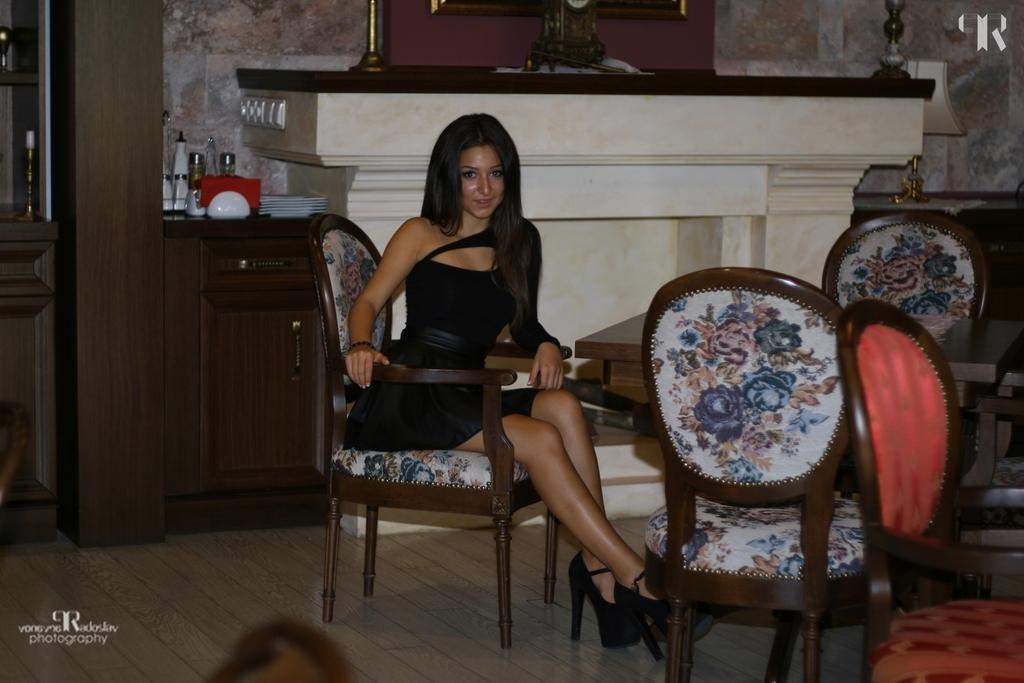Could you give a brief overview of what you see in this image? This picture shows a woman Seated on the chair and we see few chairs around and a table 